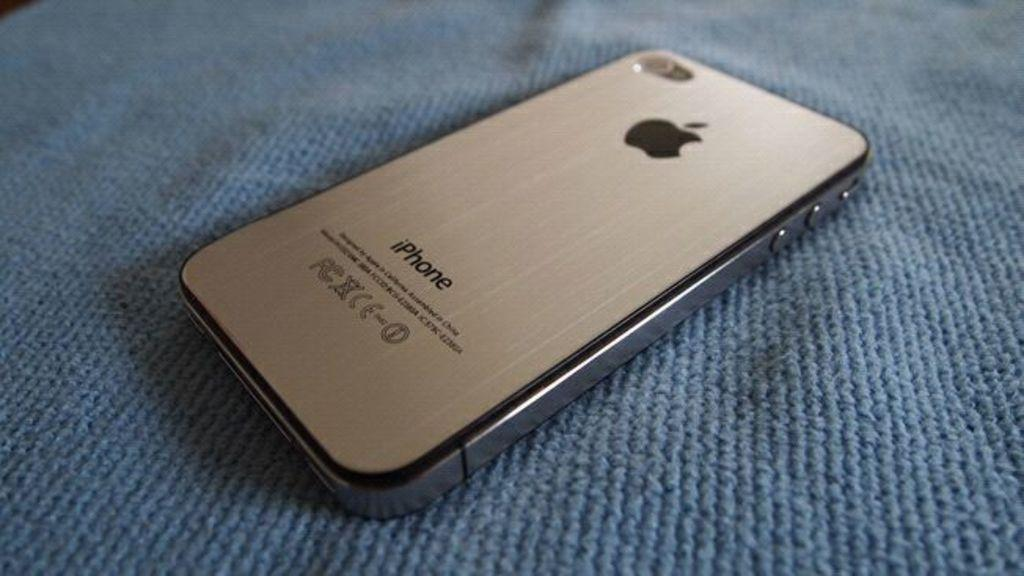<image>
Describe the image concisely. An apple iphone sits face down on a blue cloth. 